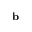<formula> <loc_0><loc_0><loc_500><loc_500>{ b }</formula> 